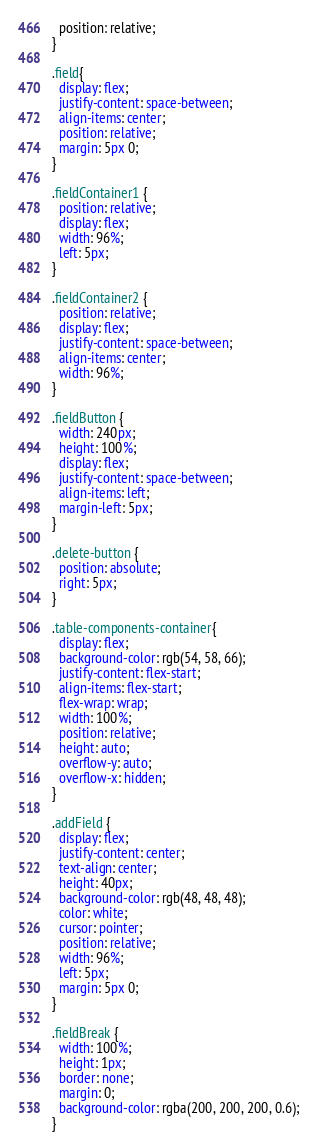Convert code to text. <code><loc_0><loc_0><loc_500><loc_500><_CSS_>  position: relative;
}

.field{
  display: flex; 
  justify-content: space-between;
  align-items: center;
  position: relative;
  margin: 5px 0;
}

.fieldContainer1 {
  position: relative;
  display: flex;
  width: 96%;
  left: 5px;
}

.fieldContainer2 {
  position: relative;
  display: flex;
  justify-content: space-between;
  align-items: center;
  width: 96%;
}

.fieldButton {
  width: 240px;
  height: 100%;
  display: flex; 
  justify-content: space-between;
  align-items: left;
  margin-left: 5px;
}

.delete-button {
  position: absolute;
  right: 5px;
}

.table-components-container{
  display: flex; 
  background-color: rgb(54, 58, 66);
  justify-content: flex-start; 
  align-items: flex-start; 
  flex-wrap: wrap; 
  width: 100%;
  position: relative;
  height: auto; 
  overflow-y: auto;
  overflow-x: hidden;
}

.addField {
  display: flex;
  justify-content: center;
  text-align: center;
  height: 40px;
  background-color: rgb(48, 48, 48);
  color: white;
  cursor: pointer;
  position: relative;
  width: 96%;
  left: 5px;
  margin: 5px 0;
}

.fieldBreak {
  width: 100%;
  height: 1px;
  border: none;
  margin: 0;
  background-color: rgba(200, 200, 200, 0.6);
}
</code> 